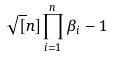Convert formula to latex. <formula><loc_0><loc_0><loc_500><loc_500>\sqrt { [ } n ] { \prod _ { i = 1 } ^ { n } \beta _ { i } } - 1</formula> 